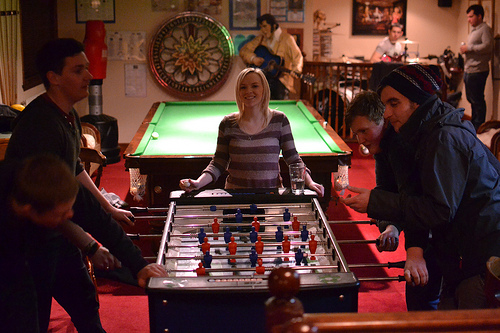<image>
Can you confirm if the table is behind the woman? Yes. From this viewpoint, the table is positioned behind the woman, with the woman partially or fully occluding the table. Is the guitar behind the man? Yes. From this viewpoint, the guitar is positioned behind the man, with the man partially or fully occluding the guitar. 